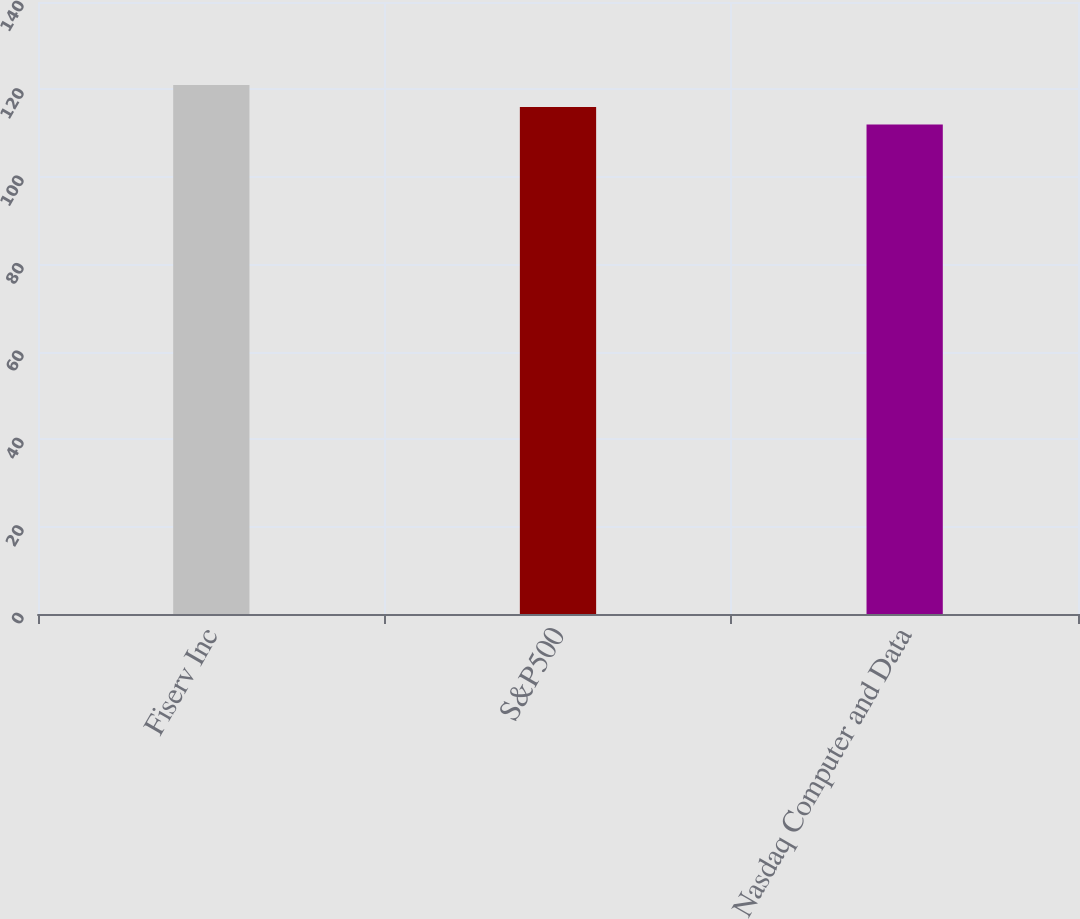Convert chart. <chart><loc_0><loc_0><loc_500><loc_500><bar_chart><fcel>Fiserv Inc<fcel>S&P500<fcel>Nasdaq Computer and Data<nl><fcel>121<fcel>116<fcel>112<nl></chart> 